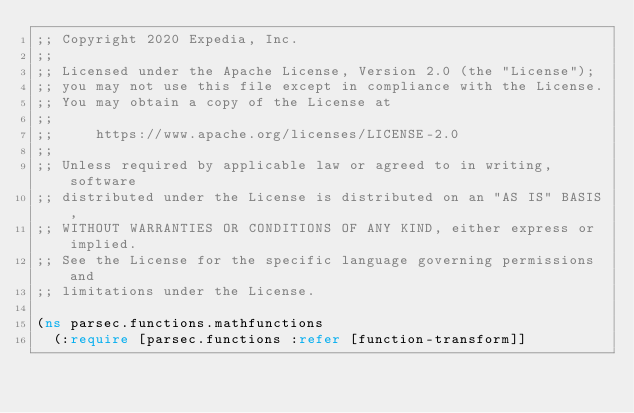<code> <loc_0><loc_0><loc_500><loc_500><_Clojure_>;; Copyright 2020 Expedia, Inc.
;;
;; Licensed under the Apache License, Version 2.0 (the "License");
;; you may not use this file except in compliance with the License.
;; You may obtain a copy of the License at
;;
;;     https://www.apache.org/licenses/LICENSE-2.0
;;
;; Unless required by applicable law or agreed to in writing, software
;; distributed under the License is distributed on an "AS IS" BASIS,
;; WITHOUT WARRANTIES OR CONDITIONS OF ANY KIND, either express or implied.
;; See the License for the specific language governing permissions and
;; limitations under the License.

(ns parsec.functions.mathfunctions
  (:require [parsec.functions :refer [function-transform]]</code> 